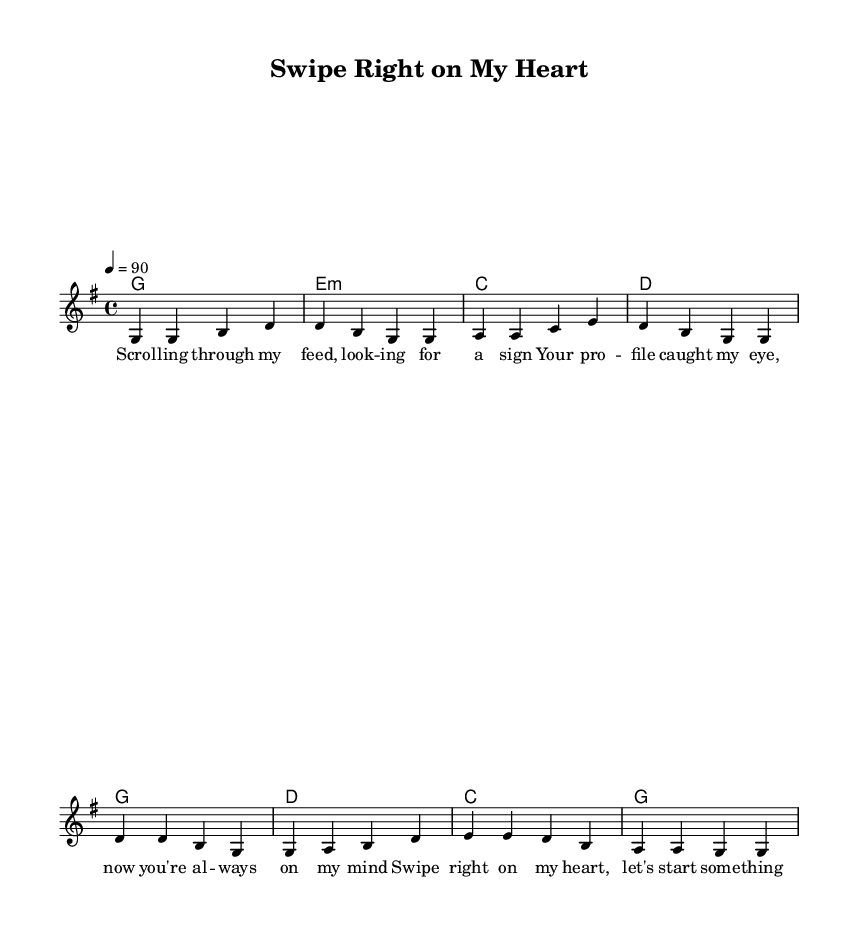What is the key signature of this music? The key signature is G major, which has one sharp. This can be identified by looking at the beginning of the staff, where it identifies the key and indicates the presence of an F sharp.
Answer: G major What is the time signature of this music? The time signature is 4/4, which can be found indicated at the beginning of the staff. This signifies that there are four beats in each measure and a quarter note receives one beat.
Answer: 4/4 What is the tempo marking of this music? The tempo marking is indicated as 4 = 90, which means there are 90 quarter note beats per minute. This sets the pace of the song as moderately fast.
Answer: 90 How many measures are in the verse section? The verse section has four measures, as it comprises four lines of music indicated before transitioning to the chorus section. Each line represents a measure and is denoted visually in the music sheet.
Answer: 4 Which chord follows the G chord in the chorus? The chord following the G chord in the chorus is D. This can be determined by looking at the chord changes specified in the score section, indicating the order of chords in the chorus section.
Answer: D What is the main theme of the lyrics? The main theme of the lyrics revolves around digital relationships and seeking connection, as depicted by phrases regarding scrolling through a feed and swiping right. This reflects contemporary interactions facilitated through social media.
Answer: Digital relationships What lyrical technique is primarily used in the chorus? The primary lyrical technique used in the chorus is repetition, with phrases like "swipe right" and "tell me how you feel" emphasizing the emotional connection and engagement over social media platforms. This reflects a common trope in modern country lyrics about romance.
Answer: Repetition 